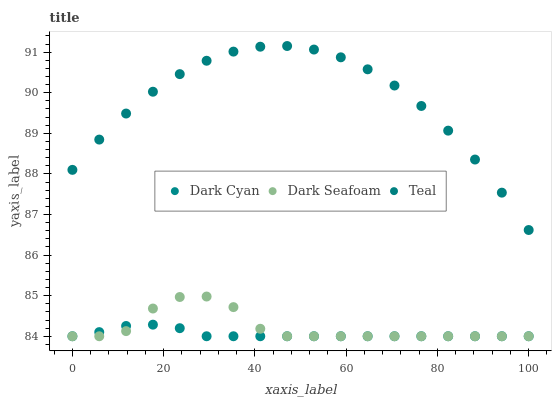Does Dark Cyan have the minimum area under the curve?
Answer yes or no. Yes. Does Teal have the maximum area under the curve?
Answer yes or no. Yes. Does Dark Seafoam have the minimum area under the curve?
Answer yes or no. No. Does Dark Seafoam have the maximum area under the curve?
Answer yes or no. No. Is Dark Cyan the smoothest?
Answer yes or no. Yes. Is Dark Seafoam the roughest?
Answer yes or no. Yes. Is Teal the smoothest?
Answer yes or no. No. Is Teal the roughest?
Answer yes or no. No. Does Dark Cyan have the lowest value?
Answer yes or no. Yes. Does Teal have the lowest value?
Answer yes or no. No. Does Teal have the highest value?
Answer yes or no. Yes. Does Dark Seafoam have the highest value?
Answer yes or no. No. Is Dark Cyan less than Teal?
Answer yes or no. Yes. Is Teal greater than Dark Cyan?
Answer yes or no. Yes. Does Dark Seafoam intersect Dark Cyan?
Answer yes or no. Yes. Is Dark Seafoam less than Dark Cyan?
Answer yes or no. No. Is Dark Seafoam greater than Dark Cyan?
Answer yes or no. No. Does Dark Cyan intersect Teal?
Answer yes or no. No. 